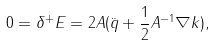<formula> <loc_0><loc_0><loc_500><loc_500>0 = \delta ^ { + } E = 2 A ( \ddot { q } + \frac { 1 } { 2 } A ^ { - 1 } \nabla k ) ,</formula> 